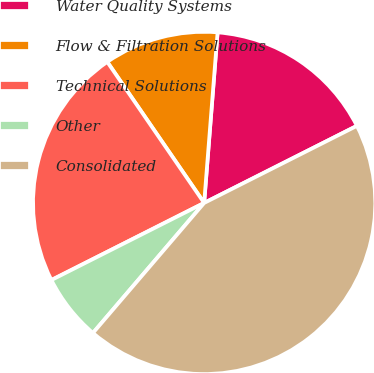<chart> <loc_0><loc_0><loc_500><loc_500><pie_chart><fcel>Water Quality Systems<fcel>Flow & Filtration Solutions<fcel>Technical Solutions<fcel>Other<fcel>Consolidated<nl><fcel>16.31%<fcel>10.83%<fcel>22.86%<fcel>6.3%<fcel>43.7%<nl></chart> 